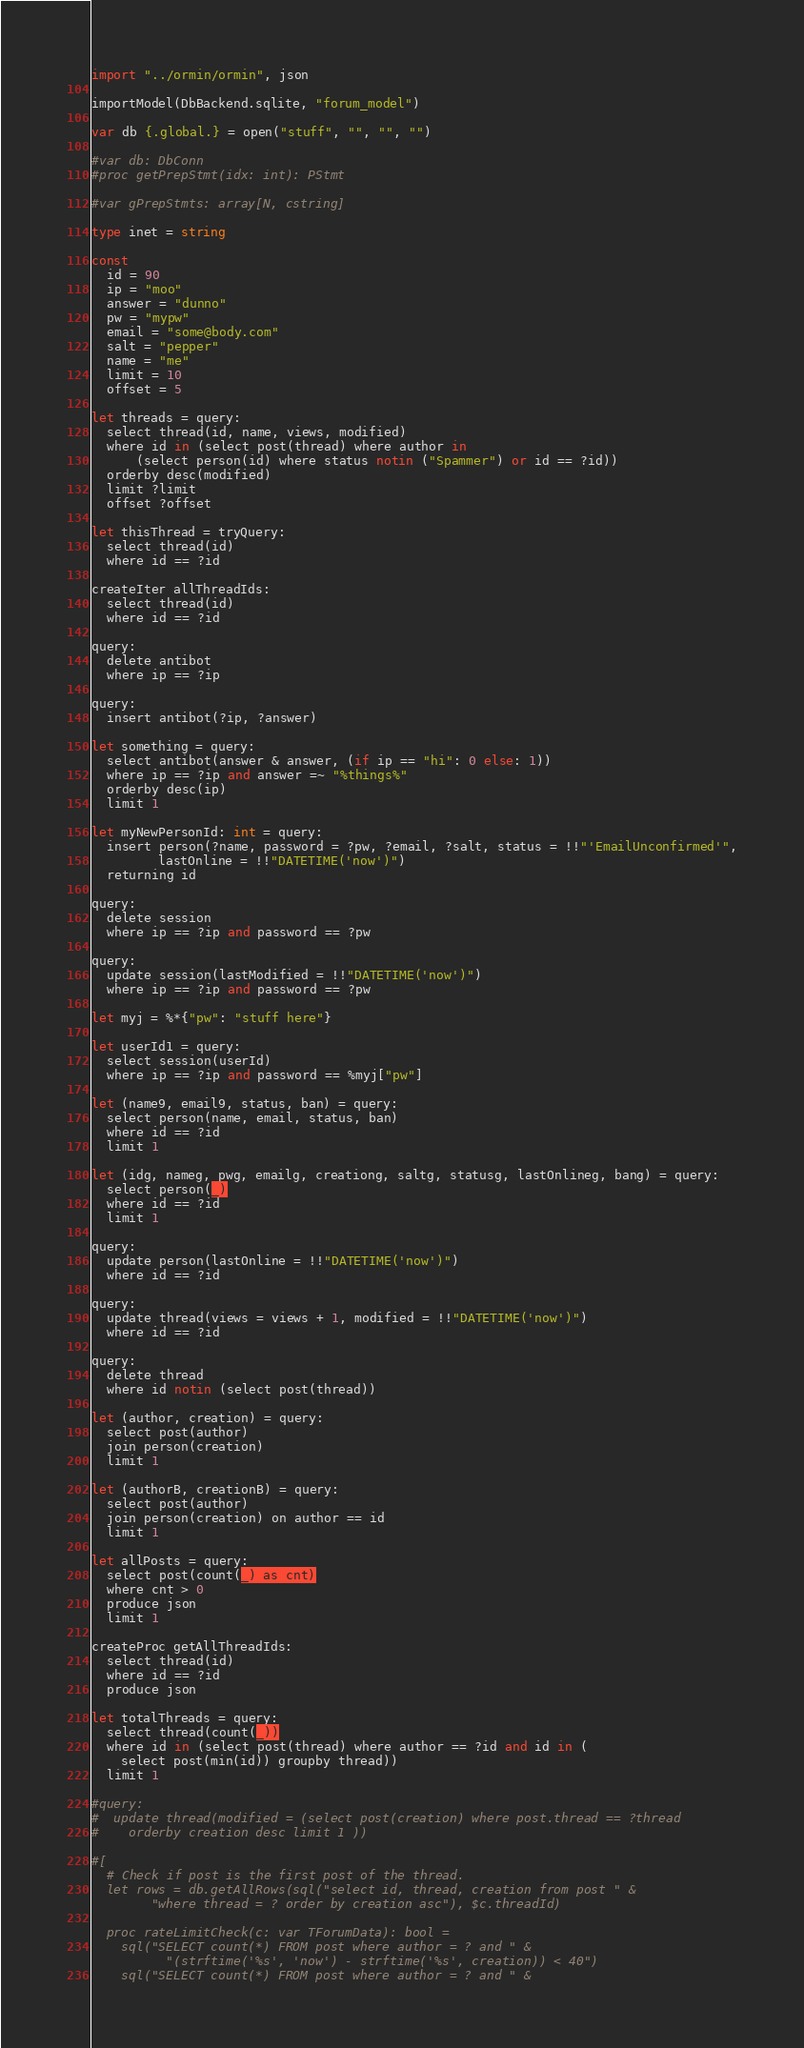Convert code to text. <code><loc_0><loc_0><loc_500><loc_500><_Nim_>
import "../ormin/ormin", json

importModel(DbBackend.sqlite, "forum_model")

var db {.global.} = open("stuff", "", "", "")

#var db: DbConn
#proc getPrepStmt(idx: int): PStmt

#var gPrepStmts: array[N, cstring]

type inet = string

const
  id = 90
  ip = "moo"
  answer = "dunno"
  pw = "mypw"
  email = "some@body.com"
  salt = "pepper"
  name = "me"
  limit = 10
  offset = 5

let threads = query:
  select thread(id, name, views, modified)
  where id in (select post(thread) where author in
      (select person(id) where status notin ("Spammer") or id == ?id))
  orderby desc(modified)
  limit ?limit
  offset ?offset

let thisThread = tryQuery:
  select thread(id)
  where id == ?id

createIter allThreadIds:
  select thread(id)
  where id == ?id

query:
  delete antibot
  where ip == ?ip

query:
  insert antibot(?ip, ?answer)

let something = query:
  select antibot(answer & answer, (if ip == "hi": 0 else: 1))
  where ip == ?ip and answer =~ "%things%"
  orderby desc(ip)
  limit 1

let myNewPersonId: int = query:
  insert person(?name, password = ?pw, ?email, ?salt, status = !!"'EmailUnconfirmed'",
         lastOnline = !!"DATETIME('now')")
  returning id

query:
  delete session
  where ip == ?ip and password == ?pw

query:
  update session(lastModified = !!"DATETIME('now')")
  where ip == ?ip and password == ?pw

let myj = %*{"pw": "stuff here"}

let userId1 = query:
  select session(userId)
  where ip == ?ip and password == %myj["pw"]

let (name9, email9, status, ban) = query:
  select person(name, email, status, ban)
  where id == ?id
  limit 1

let (idg, nameg, pwg, emailg, creationg, saltg, statusg, lastOnlineg, bang) = query:
  select person(_)
  where id == ?id
  limit 1

query:
  update person(lastOnline = !!"DATETIME('now')")
  where id == ?id

query:
  update thread(views = views + 1, modified = !!"DATETIME('now')")
  where id == ?id

query:
  delete thread
  where id notin (select post(thread))

let (author, creation) = query:
  select post(author)
  join person(creation)
  limit 1

let (authorB, creationB) = query:
  select post(author)
  join person(creation) on author == id
  limit 1

let allPosts = query:
  select post(count(_) as cnt)
  where cnt > 0
  produce json
  limit 1

createProc getAllThreadIds:
  select thread(id)
  where id == ?id
  produce json

let totalThreads = query:
  select thread(count(_))
  where id in (select post(thread) where author == ?id and id in (
    select post(min(id)) groupby thread))
  limit 1

#query:
#  update thread(modified = (select post(creation) where post.thread == ?thread
#    orderby creation desc limit 1 ))

#[
  # Check if post is the first post of the thread.
  let rows = db.getAllRows(sql("select id, thread, creation from post " &
        "where thread = ? order by creation asc"), $c.threadId)

  proc rateLimitCheck(c: var TForumData): bool =
    sql("SELECT count(*) FROM post where author = ? and " &
          "(strftime('%s', 'now') - strftime('%s', creation)) < 40")
    sql("SELECT count(*) FROM post where author = ? and " &</code> 